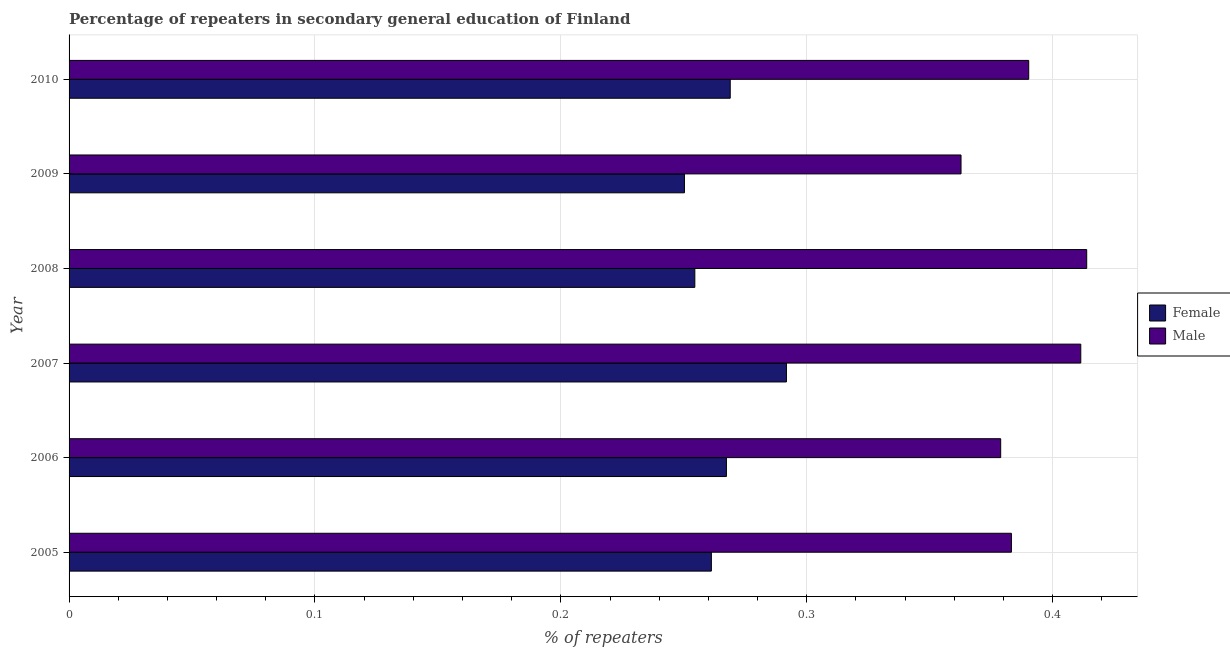How many different coloured bars are there?
Offer a terse response. 2. How many groups of bars are there?
Provide a succinct answer. 6. Are the number of bars per tick equal to the number of legend labels?
Make the answer very short. Yes. Are the number of bars on each tick of the Y-axis equal?
Your answer should be very brief. Yes. How many bars are there on the 5th tick from the bottom?
Give a very brief answer. 2. In how many cases, is the number of bars for a given year not equal to the number of legend labels?
Ensure brevity in your answer.  0. What is the percentage of male repeaters in 2005?
Provide a succinct answer. 0.38. Across all years, what is the maximum percentage of male repeaters?
Provide a short and direct response. 0.41. Across all years, what is the minimum percentage of male repeaters?
Make the answer very short. 0.36. In which year was the percentage of female repeaters maximum?
Your answer should be compact. 2007. What is the total percentage of male repeaters in the graph?
Your response must be concise. 2.34. What is the difference between the percentage of male repeaters in 2006 and that in 2007?
Offer a very short reply. -0.03. What is the difference between the percentage of female repeaters in 2009 and the percentage of male repeaters in 2006?
Make the answer very short. -0.13. What is the average percentage of female repeaters per year?
Make the answer very short. 0.27. In the year 2006, what is the difference between the percentage of male repeaters and percentage of female repeaters?
Your answer should be very brief. 0.11. Is the difference between the percentage of female repeaters in 2007 and 2008 greater than the difference between the percentage of male repeaters in 2007 and 2008?
Offer a very short reply. Yes. What is the difference between the highest and the second highest percentage of male repeaters?
Keep it short and to the point. 0. What is the difference between the highest and the lowest percentage of male repeaters?
Make the answer very short. 0.05. In how many years, is the percentage of male repeaters greater than the average percentage of male repeaters taken over all years?
Your response must be concise. 3. What does the 2nd bar from the top in 2008 represents?
Provide a short and direct response. Female. How many years are there in the graph?
Keep it short and to the point. 6. What is the difference between two consecutive major ticks on the X-axis?
Provide a short and direct response. 0.1. Does the graph contain grids?
Provide a succinct answer. Yes. How many legend labels are there?
Keep it short and to the point. 2. What is the title of the graph?
Your answer should be compact. Percentage of repeaters in secondary general education of Finland. Does "Forest" appear as one of the legend labels in the graph?
Provide a succinct answer. No. What is the label or title of the X-axis?
Provide a short and direct response. % of repeaters. What is the label or title of the Y-axis?
Offer a very short reply. Year. What is the % of repeaters of Female in 2005?
Your answer should be compact. 0.26. What is the % of repeaters in Male in 2005?
Ensure brevity in your answer.  0.38. What is the % of repeaters in Female in 2006?
Offer a very short reply. 0.27. What is the % of repeaters of Male in 2006?
Provide a succinct answer. 0.38. What is the % of repeaters of Female in 2007?
Your answer should be very brief. 0.29. What is the % of repeaters of Male in 2007?
Your answer should be compact. 0.41. What is the % of repeaters in Female in 2008?
Offer a terse response. 0.25. What is the % of repeaters of Male in 2008?
Ensure brevity in your answer.  0.41. What is the % of repeaters in Female in 2009?
Provide a short and direct response. 0.25. What is the % of repeaters in Male in 2009?
Your response must be concise. 0.36. What is the % of repeaters in Female in 2010?
Your answer should be very brief. 0.27. What is the % of repeaters in Male in 2010?
Keep it short and to the point. 0.39. Across all years, what is the maximum % of repeaters of Female?
Your answer should be very brief. 0.29. Across all years, what is the maximum % of repeaters in Male?
Your answer should be very brief. 0.41. Across all years, what is the minimum % of repeaters in Female?
Your answer should be very brief. 0.25. Across all years, what is the minimum % of repeaters in Male?
Your answer should be very brief. 0.36. What is the total % of repeaters of Female in the graph?
Offer a terse response. 1.59. What is the total % of repeaters of Male in the graph?
Give a very brief answer. 2.34. What is the difference between the % of repeaters in Female in 2005 and that in 2006?
Your answer should be compact. -0.01. What is the difference between the % of repeaters of Male in 2005 and that in 2006?
Offer a very short reply. 0. What is the difference between the % of repeaters of Female in 2005 and that in 2007?
Your answer should be very brief. -0.03. What is the difference between the % of repeaters in Male in 2005 and that in 2007?
Your answer should be very brief. -0.03. What is the difference between the % of repeaters in Female in 2005 and that in 2008?
Offer a very short reply. 0.01. What is the difference between the % of repeaters of Male in 2005 and that in 2008?
Keep it short and to the point. -0.03. What is the difference between the % of repeaters of Female in 2005 and that in 2009?
Give a very brief answer. 0.01. What is the difference between the % of repeaters in Male in 2005 and that in 2009?
Offer a very short reply. 0.02. What is the difference between the % of repeaters in Female in 2005 and that in 2010?
Offer a terse response. -0.01. What is the difference between the % of repeaters in Male in 2005 and that in 2010?
Make the answer very short. -0.01. What is the difference between the % of repeaters in Female in 2006 and that in 2007?
Your response must be concise. -0.02. What is the difference between the % of repeaters of Male in 2006 and that in 2007?
Offer a very short reply. -0.03. What is the difference between the % of repeaters in Female in 2006 and that in 2008?
Make the answer very short. 0.01. What is the difference between the % of repeaters in Male in 2006 and that in 2008?
Keep it short and to the point. -0.04. What is the difference between the % of repeaters in Female in 2006 and that in 2009?
Keep it short and to the point. 0.02. What is the difference between the % of repeaters of Male in 2006 and that in 2009?
Provide a succinct answer. 0.02. What is the difference between the % of repeaters of Female in 2006 and that in 2010?
Your answer should be compact. -0. What is the difference between the % of repeaters of Male in 2006 and that in 2010?
Offer a terse response. -0.01. What is the difference between the % of repeaters of Female in 2007 and that in 2008?
Give a very brief answer. 0.04. What is the difference between the % of repeaters of Male in 2007 and that in 2008?
Keep it short and to the point. -0. What is the difference between the % of repeaters in Female in 2007 and that in 2009?
Ensure brevity in your answer.  0.04. What is the difference between the % of repeaters in Male in 2007 and that in 2009?
Offer a very short reply. 0.05. What is the difference between the % of repeaters in Female in 2007 and that in 2010?
Give a very brief answer. 0.02. What is the difference between the % of repeaters in Male in 2007 and that in 2010?
Offer a terse response. 0.02. What is the difference between the % of repeaters of Female in 2008 and that in 2009?
Your answer should be compact. 0. What is the difference between the % of repeaters in Male in 2008 and that in 2009?
Offer a terse response. 0.05. What is the difference between the % of repeaters in Female in 2008 and that in 2010?
Keep it short and to the point. -0.01. What is the difference between the % of repeaters in Male in 2008 and that in 2010?
Make the answer very short. 0.02. What is the difference between the % of repeaters of Female in 2009 and that in 2010?
Offer a very short reply. -0.02. What is the difference between the % of repeaters in Male in 2009 and that in 2010?
Provide a short and direct response. -0.03. What is the difference between the % of repeaters of Female in 2005 and the % of repeaters of Male in 2006?
Make the answer very short. -0.12. What is the difference between the % of repeaters of Female in 2005 and the % of repeaters of Male in 2007?
Your answer should be compact. -0.15. What is the difference between the % of repeaters in Female in 2005 and the % of repeaters in Male in 2008?
Make the answer very short. -0.15. What is the difference between the % of repeaters of Female in 2005 and the % of repeaters of Male in 2009?
Your response must be concise. -0.1. What is the difference between the % of repeaters in Female in 2005 and the % of repeaters in Male in 2010?
Your response must be concise. -0.13. What is the difference between the % of repeaters of Female in 2006 and the % of repeaters of Male in 2007?
Your answer should be compact. -0.14. What is the difference between the % of repeaters of Female in 2006 and the % of repeaters of Male in 2008?
Your answer should be very brief. -0.15. What is the difference between the % of repeaters in Female in 2006 and the % of repeaters in Male in 2009?
Offer a very short reply. -0.1. What is the difference between the % of repeaters of Female in 2006 and the % of repeaters of Male in 2010?
Offer a very short reply. -0.12. What is the difference between the % of repeaters in Female in 2007 and the % of repeaters in Male in 2008?
Provide a succinct answer. -0.12. What is the difference between the % of repeaters in Female in 2007 and the % of repeaters in Male in 2009?
Provide a succinct answer. -0.07. What is the difference between the % of repeaters of Female in 2007 and the % of repeaters of Male in 2010?
Provide a short and direct response. -0.1. What is the difference between the % of repeaters of Female in 2008 and the % of repeaters of Male in 2009?
Give a very brief answer. -0.11. What is the difference between the % of repeaters in Female in 2008 and the % of repeaters in Male in 2010?
Make the answer very short. -0.14. What is the difference between the % of repeaters of Female in 2009 and the % of repeaters of Male in 2010?
Give a very brief answer. -0.14. What is the average % of repeaters in Female per year?
Offer a terse response. 0.27. What is the average % of repeaters in Male per year?
Provide a succinct answer. 0.39. In the year 2005, what is the difference between the % of repeaters in Female and % of repeaters in Male?
Your response must be concise. -0.12. In the year 2006, what is the difference between the % of repeaters of Female and % of repeaters of Male?
Provide a short and direct response. -0.11. In the year 2007, what is the difference between the % of repeaters in Female and % of repeaters in Male?
Keep it short and to the point. -0.12. In the year 2008, what is the difference between the % of repeaters of Female and % of repeaters of Male?
Your response must be concise. -0.16. In the year 2009, what is the difference between the % of repeaters in Female and % of repeaters in Male?
Your answer should be compact. -0.11. In the year 2010, what is the difference between the % of repeaters in Female and % of repeaters in Male?
Offer a very short reply. -0.12. What is the ratio of the % of repeaters of Female in 2005 to that in 2006?
Keep it short and to the point. 0.98. What is the ratio of the % of repeaters in Male in 2005 to that in 2006?
Provide a succinct answer. 1.01. What is the ratio of the % of repeaters of Female in 2005 to that in 2007?
Your answer should be compact. 0.9. What is the ratio of the % of repeaters of Male in 2005 to that in 2007?
Give a very brief answer. 0.93. What is the ratio of the % of repeaters of Female in 2005 to that in 2008?
Give a very brief answer. 1.03. What is the ratio of the % of repeaters of Male in 2005 to that in 2008?
Your response must be concise. 0.93. What is the ratio of the % of repeaters of Female in 2005 to that in 2009?
Offer a terse response. 1.04. What is the ratio of the % of repeaters in Male in 2005 to that in 2009?
Provide a succinct answer. 1.06. What is the ratio of the % of repeaters of Female in 2005 to that in 2010?
Provide a short and direct response. 0.97. What is the ratio of the % of repeaters of Female in 2006 to that in 2007?
Ensure brevity in your answer.  0.92. What is the ratio of the % of repeaters of Male in 2006 to that in 2007?
Provide a short and direct response. 0.92. What is the ratio of the % of repeaters of Female in 2006 to that in 2008?
Provide a succinct answer. 1.05. What is the ratio of the % of repeaters of Male in 2006 to that in 2008?
Provide a succinct answer. 0.92. What is the ratio of the % of repeaters of Female in 2006 to that in 2009?
Your answer should be compact. 1.07. What is the ratio of the % of repeaters of Male in 2006 to that in 2009?
Offer a very short reply. 1.04. What is the ratio of the % of repeaters of Male in 2006 to that in 2010?
Keep it short and to the point. 0.97. What is the ratio of the % of repeaters in Female in 2007 to that in 2008?
Keep it short and to the point. 1.15. What is the ratio of the % of repeaters of Female in 2007 to that in 2009?
Offer a very short reply. 1.17. What is the ratio of the % of repeaters of Male in 2007 to that in 2009?
Keep it short and to the point. 1.13. What is the ratio of the % of repeaters of Female in 2007 to that in 2010?
Ensure brevity in your answer.  1.08. What is the ratio of the % of repeaters in Male in 2007 to that in 2010?
Provide a succinct answer. 1.05. What is the ratio of the % of repeaters of Female in 2008 to that in 2009?
Provide a succinct answer. 1.02. What is the ratio of the % of repeaters of Male in 2008 to that in 2009?
Offer a terse response. 1.14. What is the ratio of the % of repeaters of Female in 2008 to that in 2010?
Provide a short and direct response. 0.95. What is the ratio of the % of repeaters of Male in 2008 to that in 2010?
Your answer should be compact. 1.06. What is the ratio of the % of repeaters in Female in 2009 to that in 2010?
Provide a succinct answer. 0.93. What is the ratio of the % of repeaters of Male in 2009 to that in 2010?
Give a very brief answer. 0.93. What is the difference between the highest and the second highest % of repeaters of Female?
Give a very brief answer. 0.02. What is the difference between the highest and the second highest % of repeaters in Male?
Keep it short and to the point. 0. What is the difference between the highest and the lowest % of repeaters in Female?
Your response must be concise. 0.04. What is the difference between the highest and the lowest % of repeaters of Male?
Offer a terse response. 0.05. 